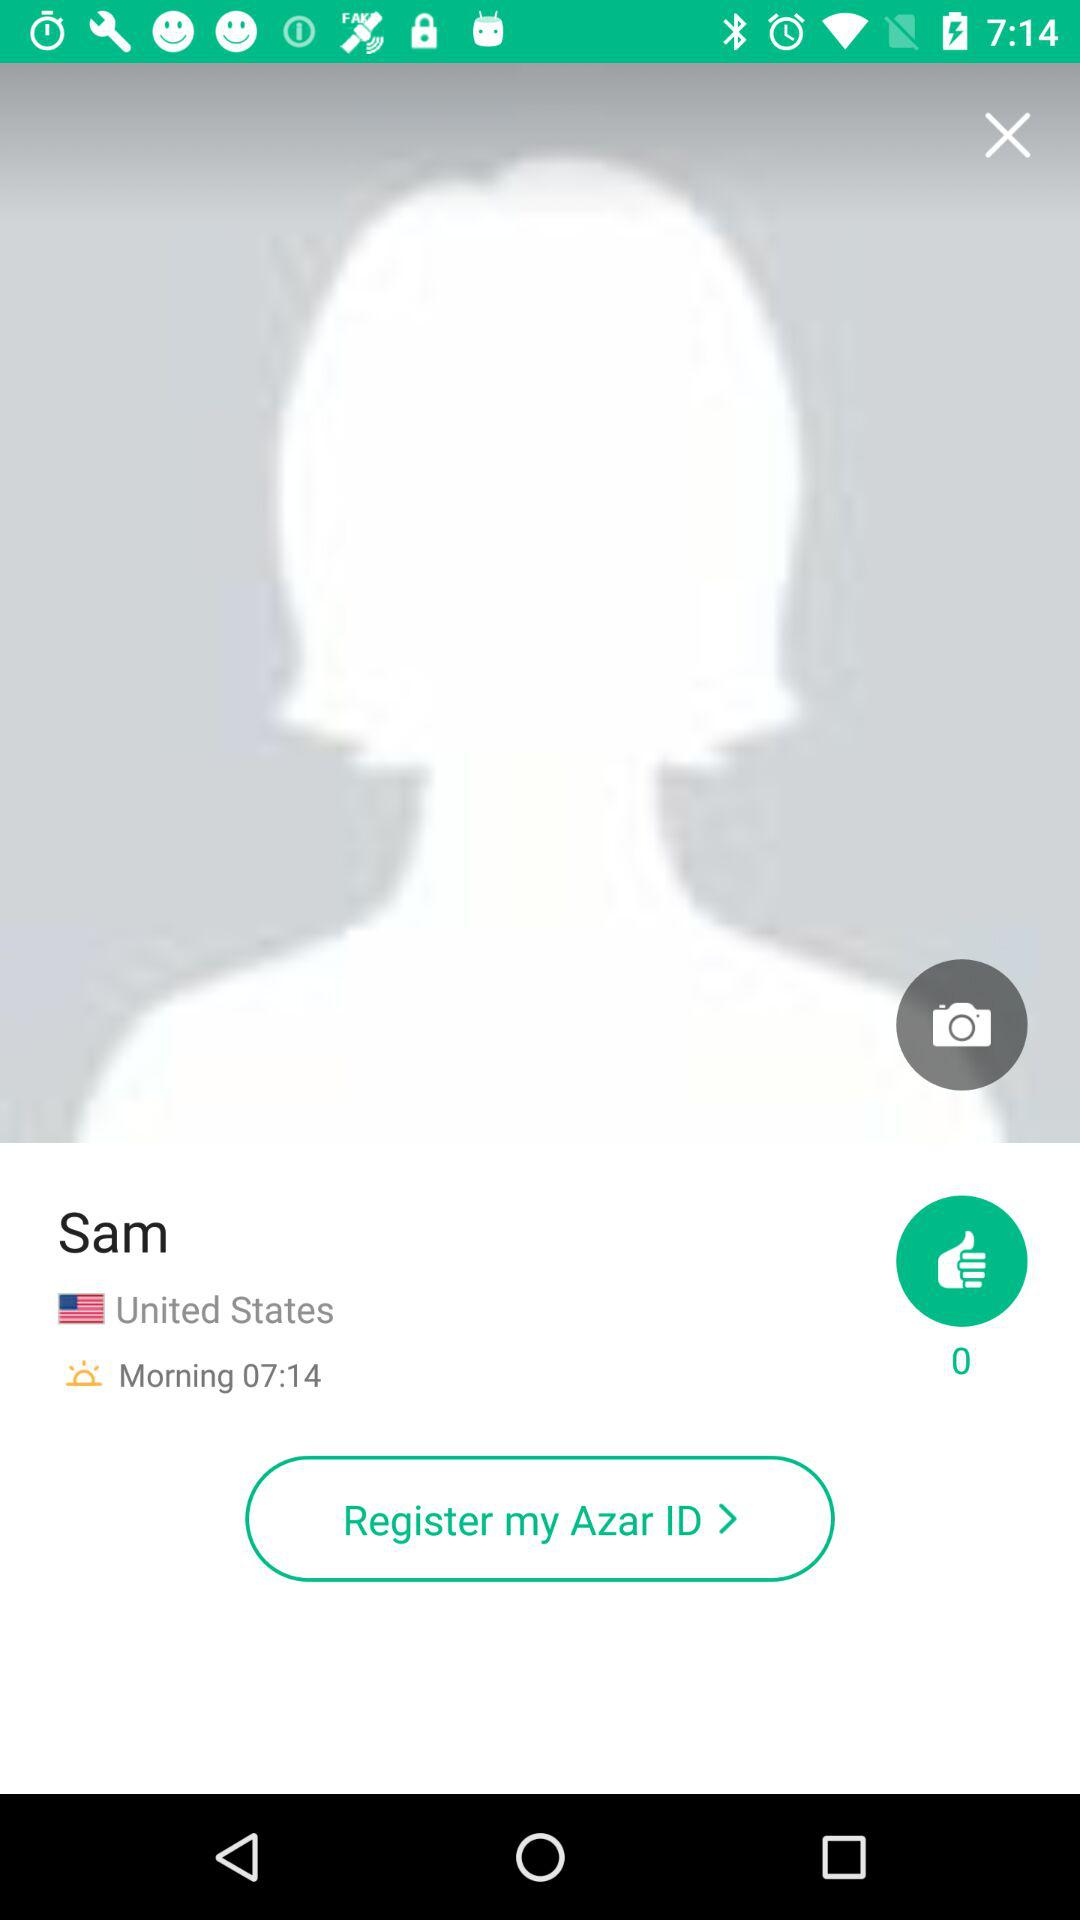What time is mentioned? The mentioned time is 07:14 a.m. 